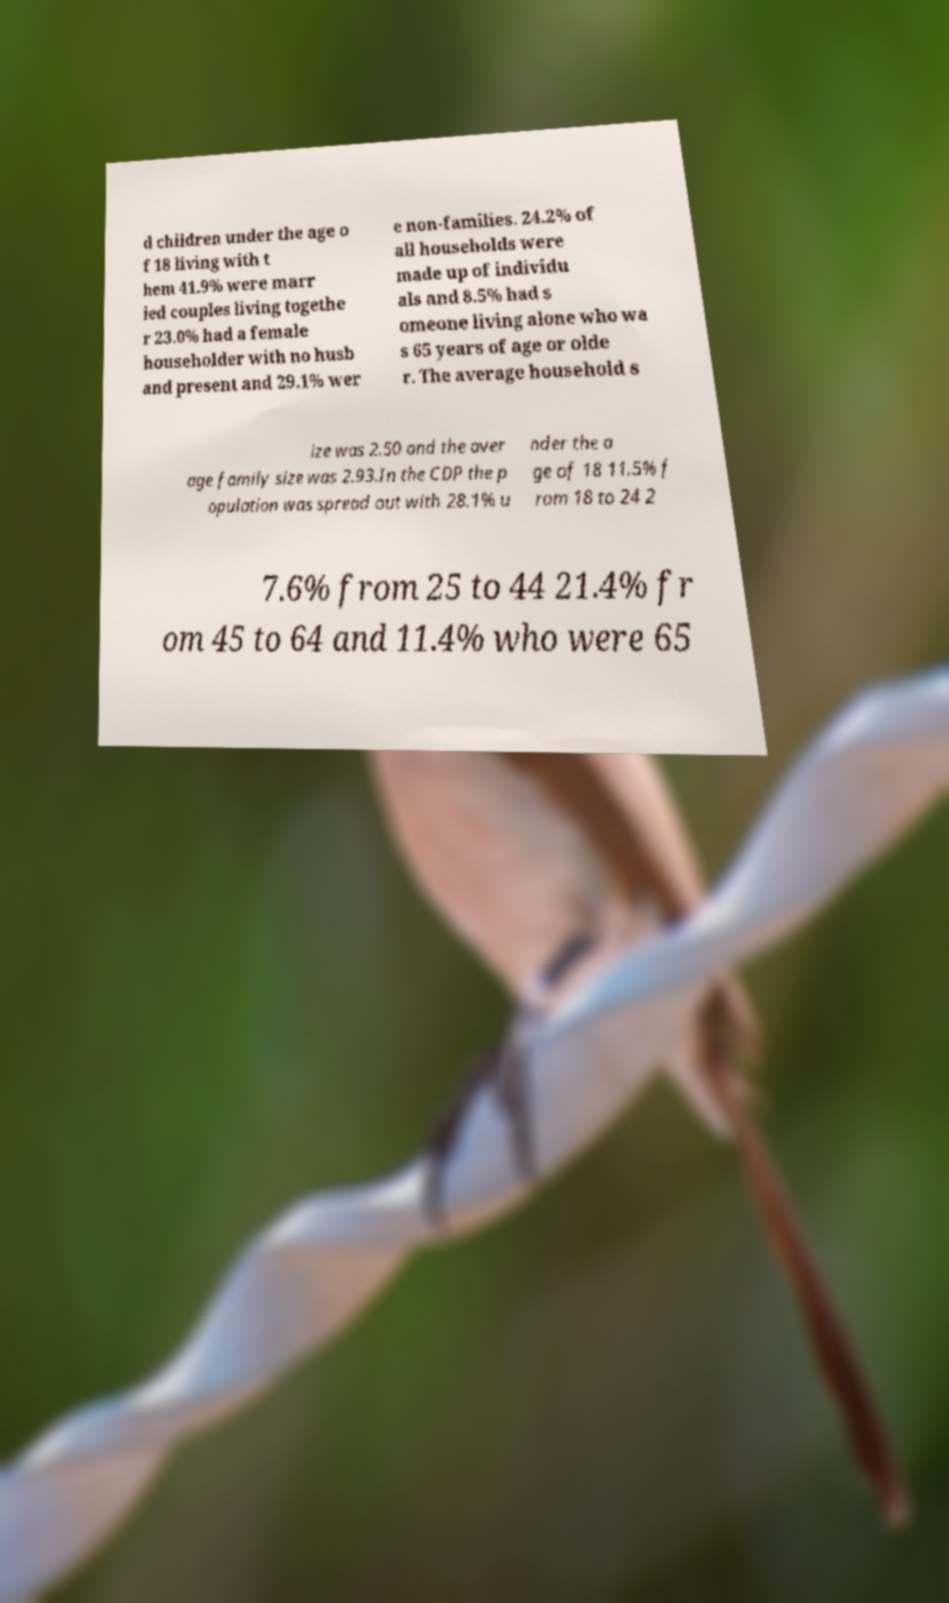I need the written content from this picture converted into text. Can you do that? d children under the age o f 18 living with t hem 41.9% were marr ied couples living togethe r 23.0% had a female householder with no husb and present and 29.1% wer e non-families. 24.2% of all households were made up of individu als and 8.5% had s omeone living alone who wa s 65 years of age or olde r. The average household s ize was 2.50 and the aver age family size was 2.93.In the CDP the p opulation was spread out with 28.1% u nder the a ge of 18 11.5% f rom 18 to 24 2 7.6% from 25 to 44 21.4% fr om 45 to 64 and 11.4% who were 65 